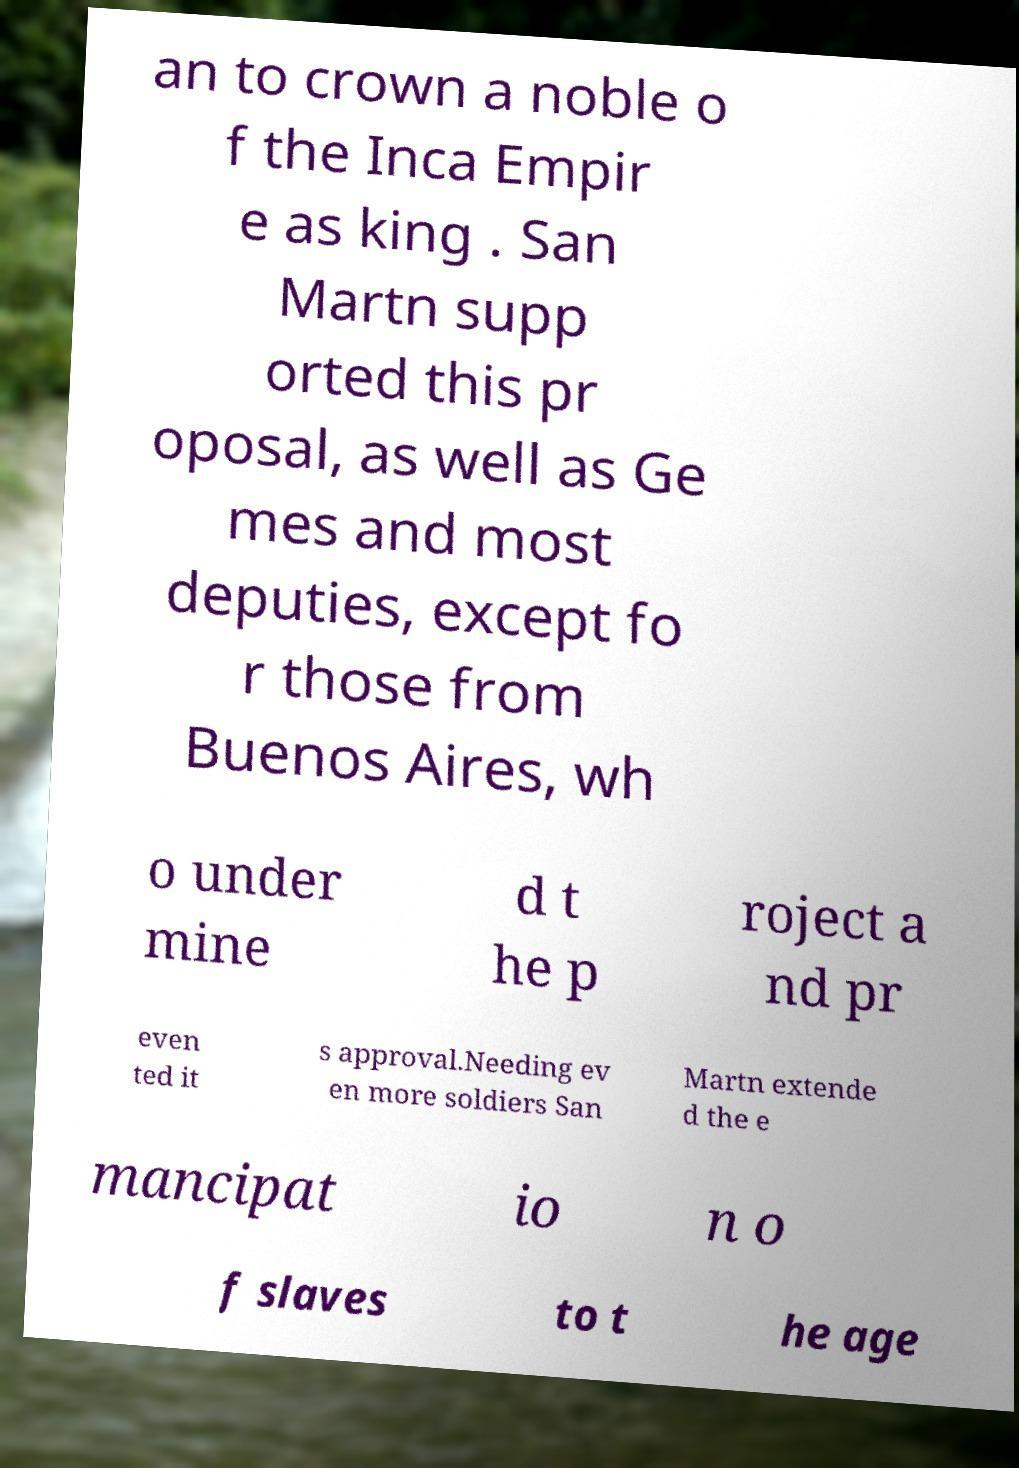What messages or text are displayed in this image? I need them in a readable, typed format. an to crown a noble o f the Inca Empir e as king . San Martn supp orted this pr oposal, as well as Ge mes and most deputies, except fo r those from Buenos Aires, wh o under mine d t he p roject a nd pr even ted it s approval.Needing ev en more soldiers San Martn extende d the e mancipat io n o f slaves to t he age 